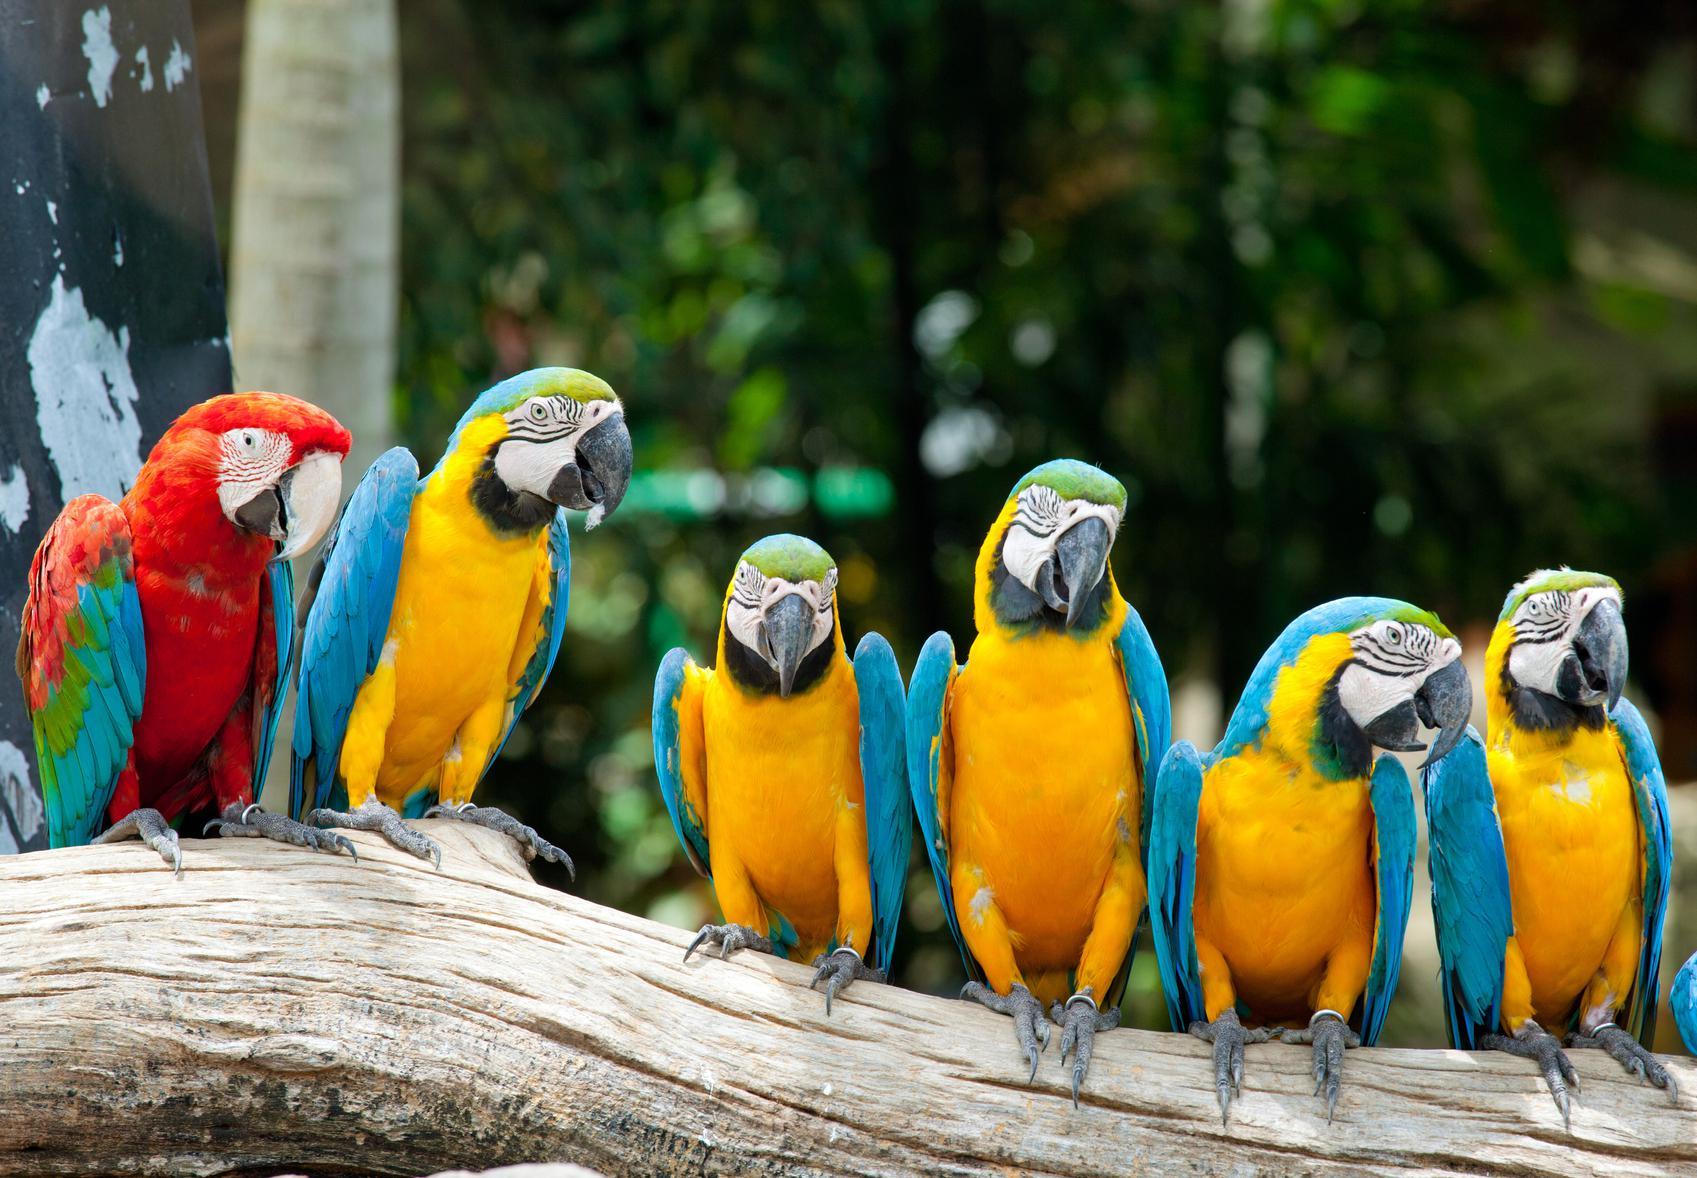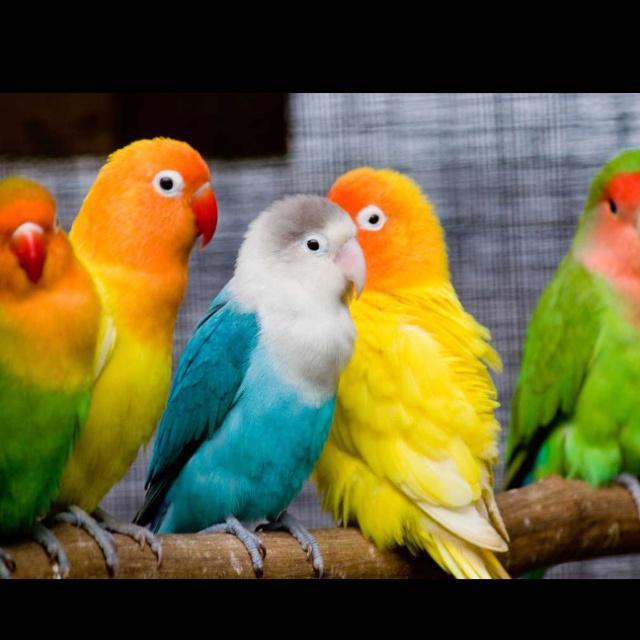The first image is the image on the left, the second image is the image on the right. Assess this claim about the two images: "The parrot in the right image closest to the right side is blue and yellow.". Correct or not? Answer yes or no. No. The first image is the image on the left, the second image is the image on the right. For the images shown, is this caption "There are six colorful birds perched on a piece of wood in the image on the left." true? Answer yes or no. Yes. 